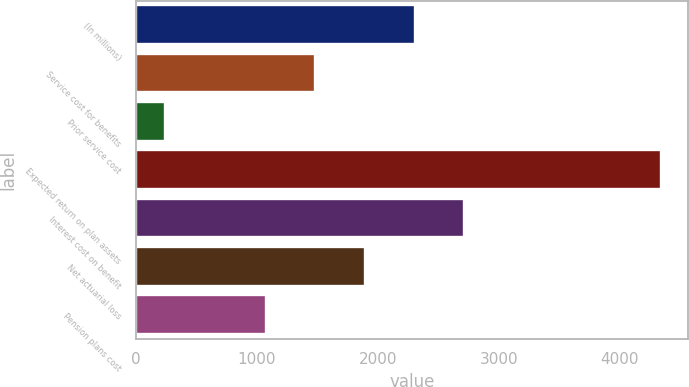Convert chart to OTSL. <chart><loc_0><loc_0><loc_500><loc_500><bar_chart><fcel>(In millions)<fcel>Service cost for benefits<fcel>Prior service cost<fcel>Expected return on plan assets<fcel>Interest cost on benefit<fcel>Net actuarial loss<fcel>Pension plans cost<nl><fcel>2303.8<fcel>1482.6<fcel>238<fcel>4344<fcel>2714.4<fcel>1893.2<fcel>1072<nl></chart> 